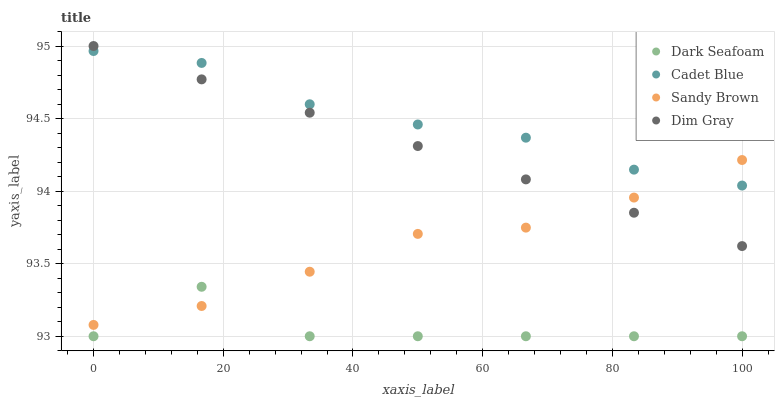Does Dark Seafoam have the minimum area under the curve?
Answer yes or no. Yes. Does Cadet Blue have the maximum area under the curve?
Answer yes or no. Yes. Does Sandy Brown have the minimum area under the curve?
Answer yes or no. No. Does Sandy Brown have the maximum area under the curve?
Answer yes or no. No. Is Dim Gray the smoothest?
Answer yes or no. Yes. Is Dark Seafoam the roughest?
Answer yes or no. Yes. Is Cadet Blue the smoothest?
Answer yes or no. No. Is Cadet Blue the roughest?
Answer yes or no. No. Does Dark Seafoam have the lowest value?
Answer yes or no. Yes. Does Sandy Brown have the lowest value?
Answer yes or no. No. Does Dim Gray have the highest value?
Answer yes or no. Yes. Does Cadet Blue have the highest value?
Answer yes or no. No. Is Dark Seafoam less than Dim Gray?
Answer yes or no. Yes. Is Cadet Blue greater than Dark Seafoam?
Answer yes or no. Yes. Does Sandy Brown intersect Dark Seafoam?
Answer yes or no. Yes. Is Sandy Brown less than Dark Seafoam?
Answer yes or no. No. Is Sandy Brown greater than Dark Seafoam?
Answer yes or no. No. Does Dark Seafoam intersect Dim Gray?
Answer yes or no. No. 